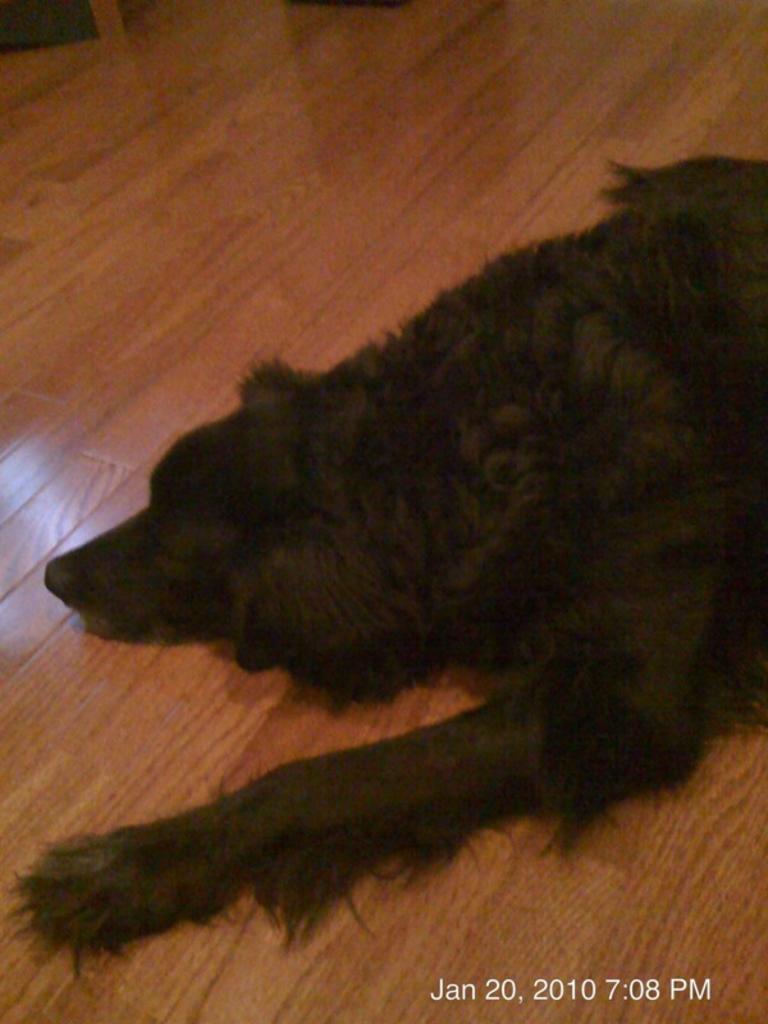Could you give a brief overview of what you see in this image? The picture consists of a dog lying on a wooden floor. At the top left there is an object. At the bottom towards right there is date and time. 